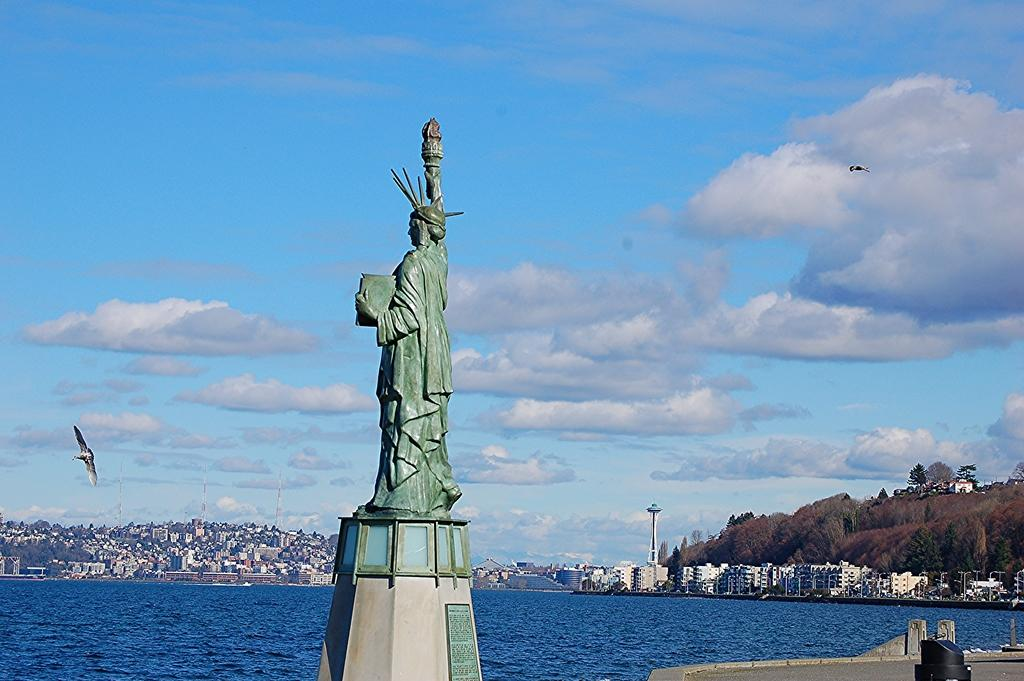What is the main subject in the front of the image? There is a statue in the front of the image. What is located in the center of the image? There is water in the center of the image. What can be seen in the background of the image? There are buildings and trees in the background of the image. How would you describe the sky in the image? The sky is cloudy in the image. What else is visible in the sky? There are birds flying in the sky. How many pizzas are being played on the chessboard in the image? There are no pizzas or chessboards present in the image. What type of rod is being used to catch fish in the image? There is no rod or fishing activity depicted in the image. 